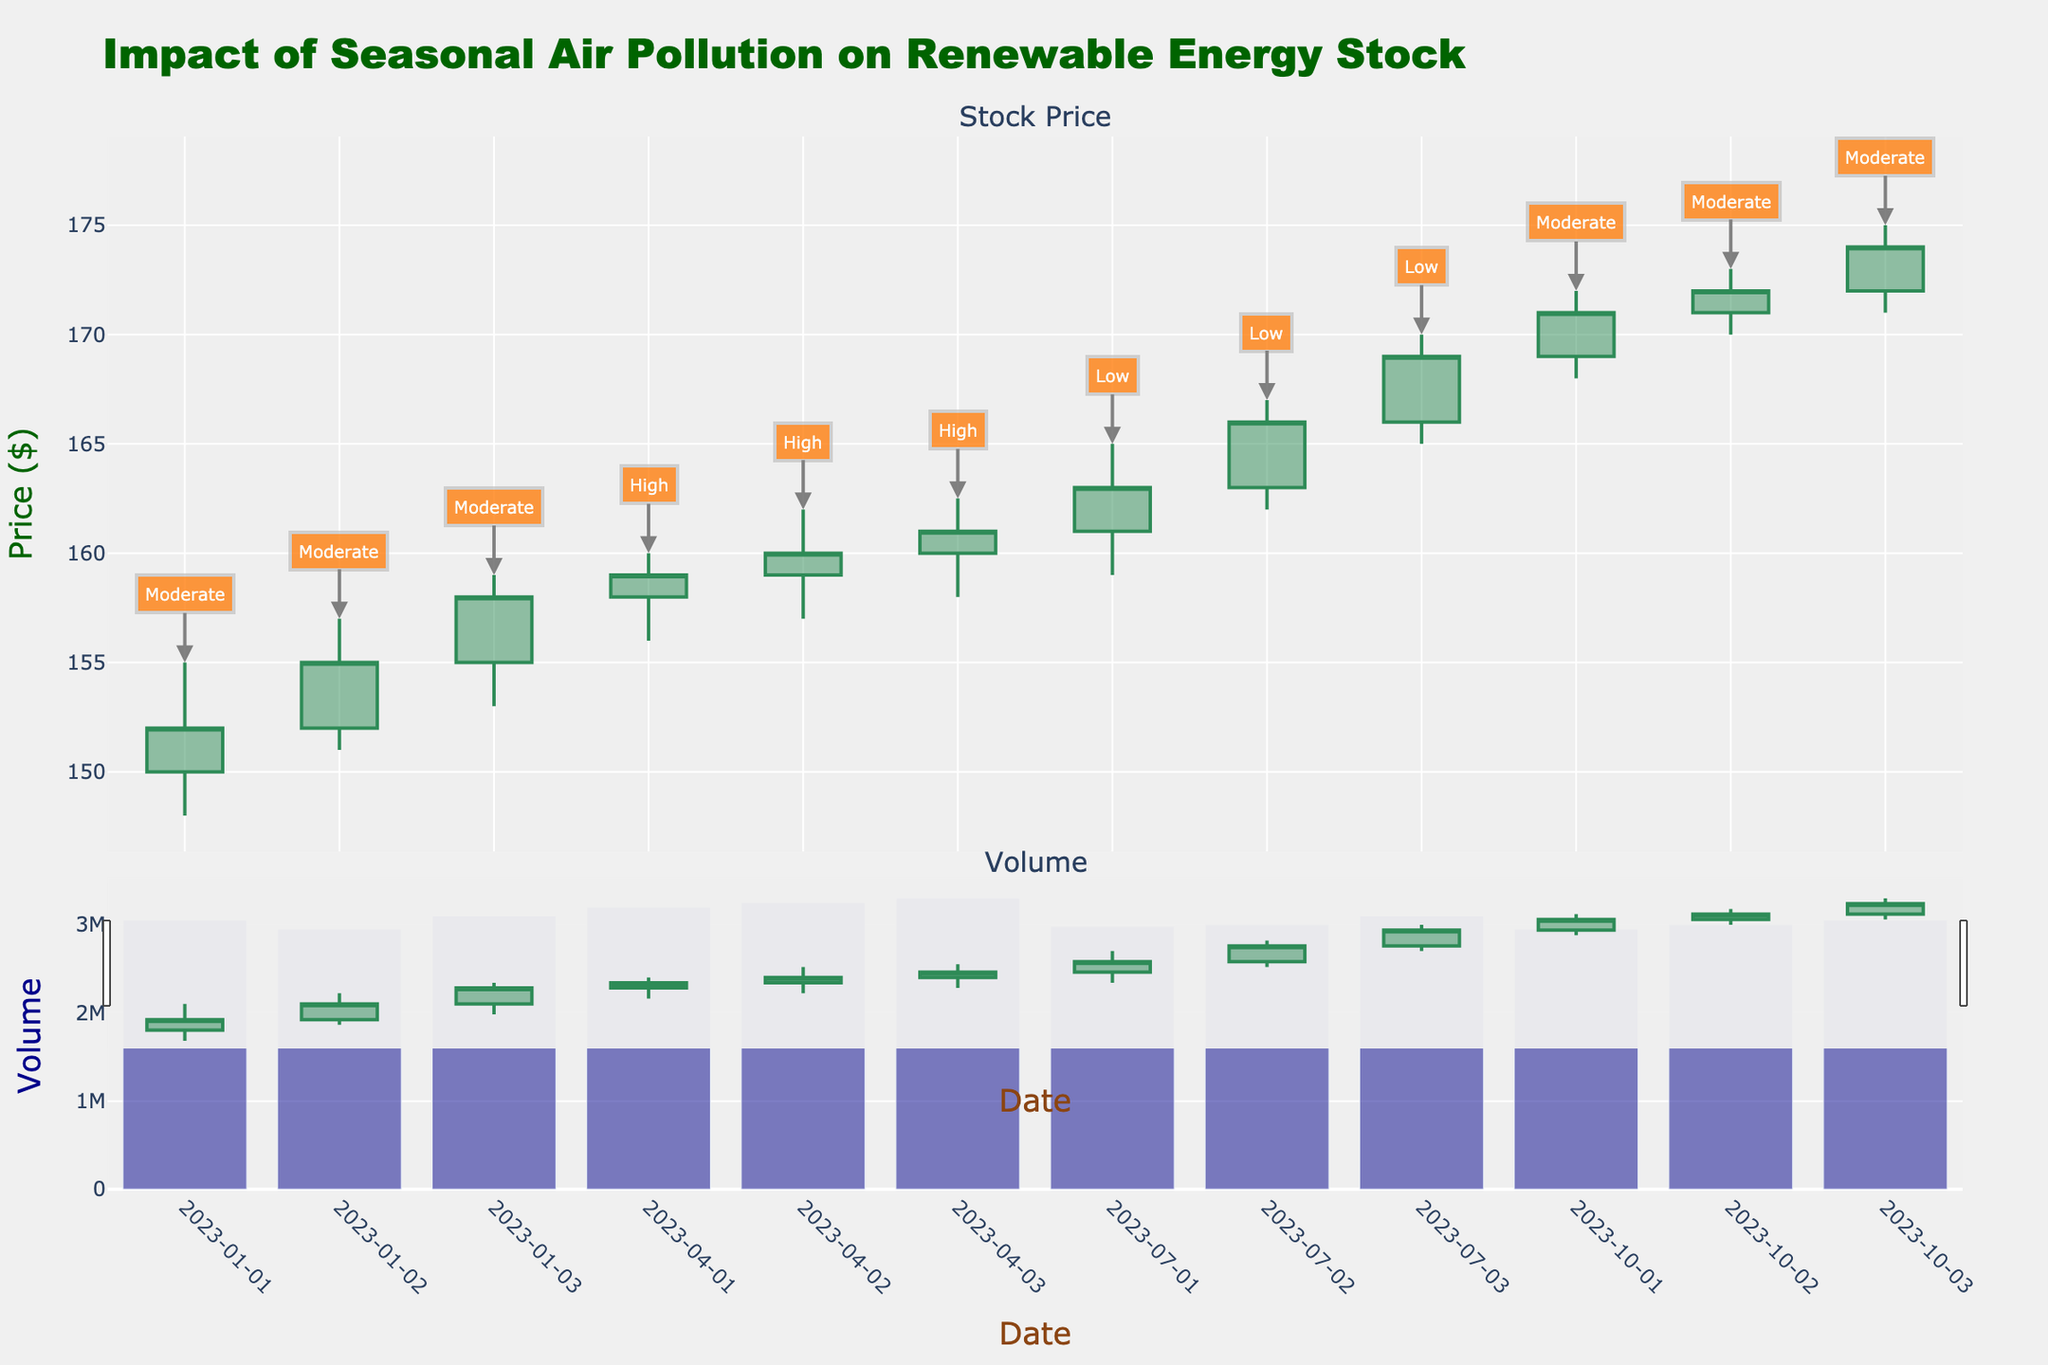What is the title of the plot? The title is displayed at the top of the plot and usually summarizes the main focus of the figure.
Answer: Impact of Seasonal Air Pollution on Renewable Energy Stock What is the y-axis label for the volume subplot? The y-axis label is located along the left side of the volume subplot, indicating the metric being measured in this part.
Answer: Volume How does the stock price on January 3rd compare to January 1st? By looking at the close prices for January 1st ($152.00) and January 3rd ($158.00), we can see that the stock price has increased.
Answer: It increased What was the highest stock price reached on July 3rd? To find the highest stock price on July 3rd, refer to the "High" column for that date.
Answer: $170.00 How does the volume on July 2nd compare to that on January 2nd? According to the volume subplot, the volume on July 2nd is 3,000,000, while on January 2nd, it's 2,950,000. July 2nd has a higher volume.
Answer: July 2nd has a higher volume What is the average closing price for all dates in October 2023? To find the average closing price for October, add up the closing prices for the three dates in October (171.00 + 172.00 + 174.00) and divide by 3.
Answer: 172.33 During which month was the pollution level highest, according to the plot annotations? By looking at the annotations for pollution levels, April is labeled "High" while January, July, and October have lower levels.
Answer: April How does the stock performance during high pollution levels in April compare to moderate pollution levels in January? Comparing closing prices from April (159.00, 160.00, 161.00) to January (152.00, 155.00, 158.00), we see prices tend to be higher in April.
Answer: Higher in April Which month shows a steady increase in stock prices over three days? By observing the candlestick plot, it's clear that July shows a steady increase in stock prices each of the three days.
Answer: July What trend can be observed in the stock prices during low pollution levels in July? By examining stock prices in July (163.00, 166.00, 169.00), there is a noticeable upward trend where the stock prices increase each day.
Answer: Upward trend 